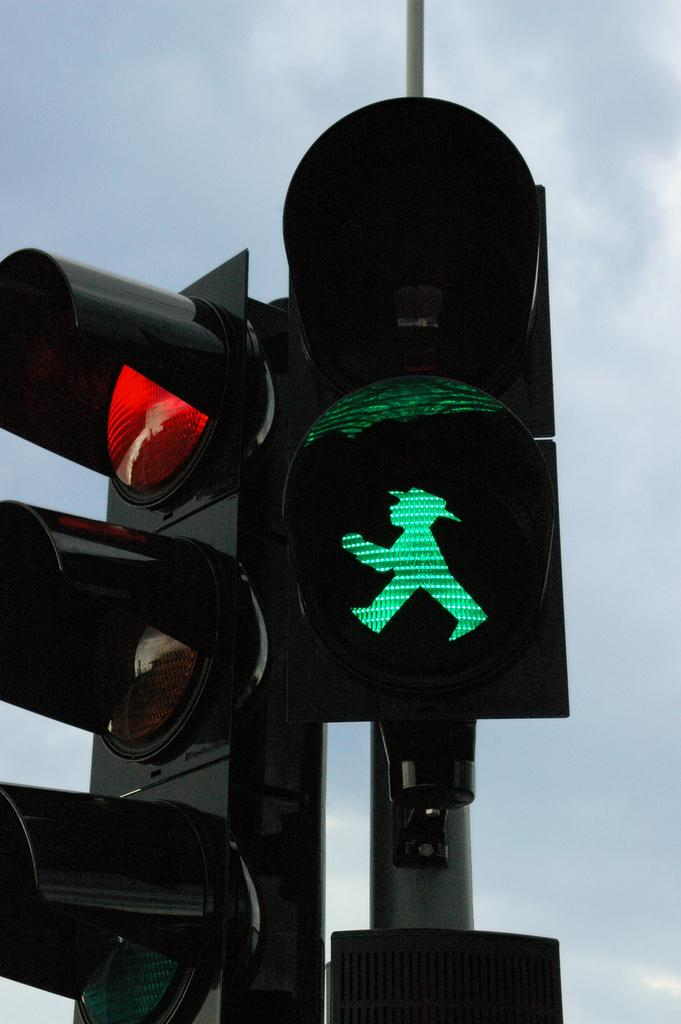What can be seen in the image that helps regulate traffic? There are traffic signals in the image. How are the traffic signals positioned in the image? The traffic signals are fixed to poles. What can be seen in the background of the image? There is a sky visible in the background of the image. Are there any ice bears visible in the image? There are no ice bears present in the image. What type of sign can be seen in the image? There is no sign visible in the image; only traffic signals and poles are present. 